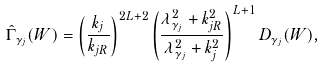<formula> <loc_0><loc_0><loc_500><loc_500>\hat { \Gamma } _ { \gamma _ { j } } ( W ) = \left ( \frac { k _ { j } } { k _ { j R } } \right ) ^ { 2 L + 2 } \left ( \frac { \lambda _ { \gamma _ { j } } ^ { 2 } + k ^ { 2 } _ { j R } } { \lambda _ { \gamma _ { j } } ^ { 2 } + k ^ { 2 } _ { j } } \right ) ^ { L + 1 } D _ { \gamma _ { j } } ( W ) ,</formula> 